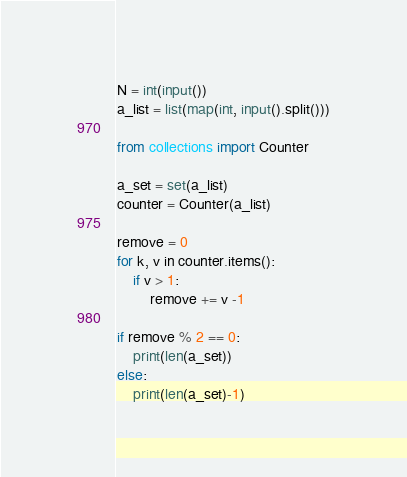Convert code to text. <code><loc_0><loc_0><loc_500><loc_500><_Python_>N = int(input())
a_list = list(map(int, input().split()))

from collections import Counter

a_set = set(a_list)
counter = Counter(a_list)

remove = 0
for k, v in counter.items():
    if v > 1:
        remove += v -1

if remove % 2 == 0:
    print(len(a_set))
else:
    print(len(a_set)-1)</code> 